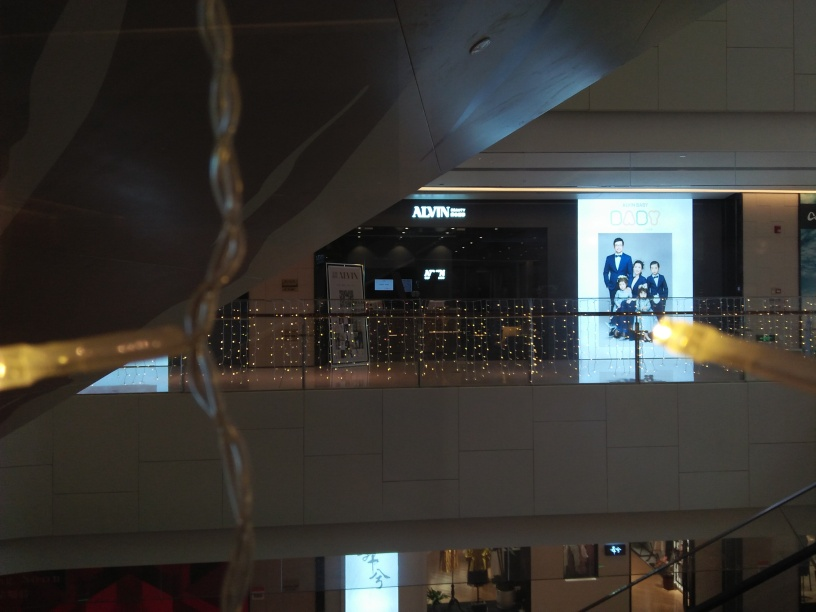Can you guess the time of year or season this picture may have been taken? While the image doesn't offer explicit seasonal clues, the warm lighting and decorative style could suggest a time around the winter holidays. Such lighting is often associated with festive seasons, promoting a cheerful and inviting shopping experience. 